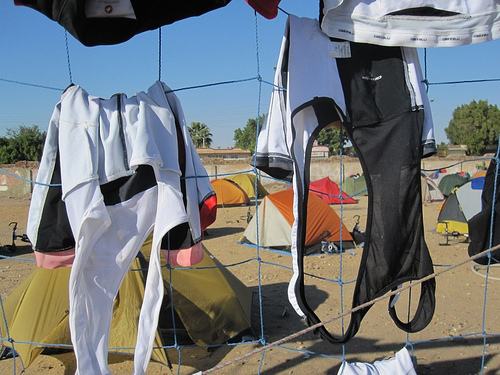<image>
Is the tent behind the clothes? Yes. From this viewpoint, the tent is positioned behind the clothes, with the clothes partially or fully occluding the tent. Is there a clothing in the fence? Yes. The clothing is contained within or inside the fence, showing a containment relationship. 